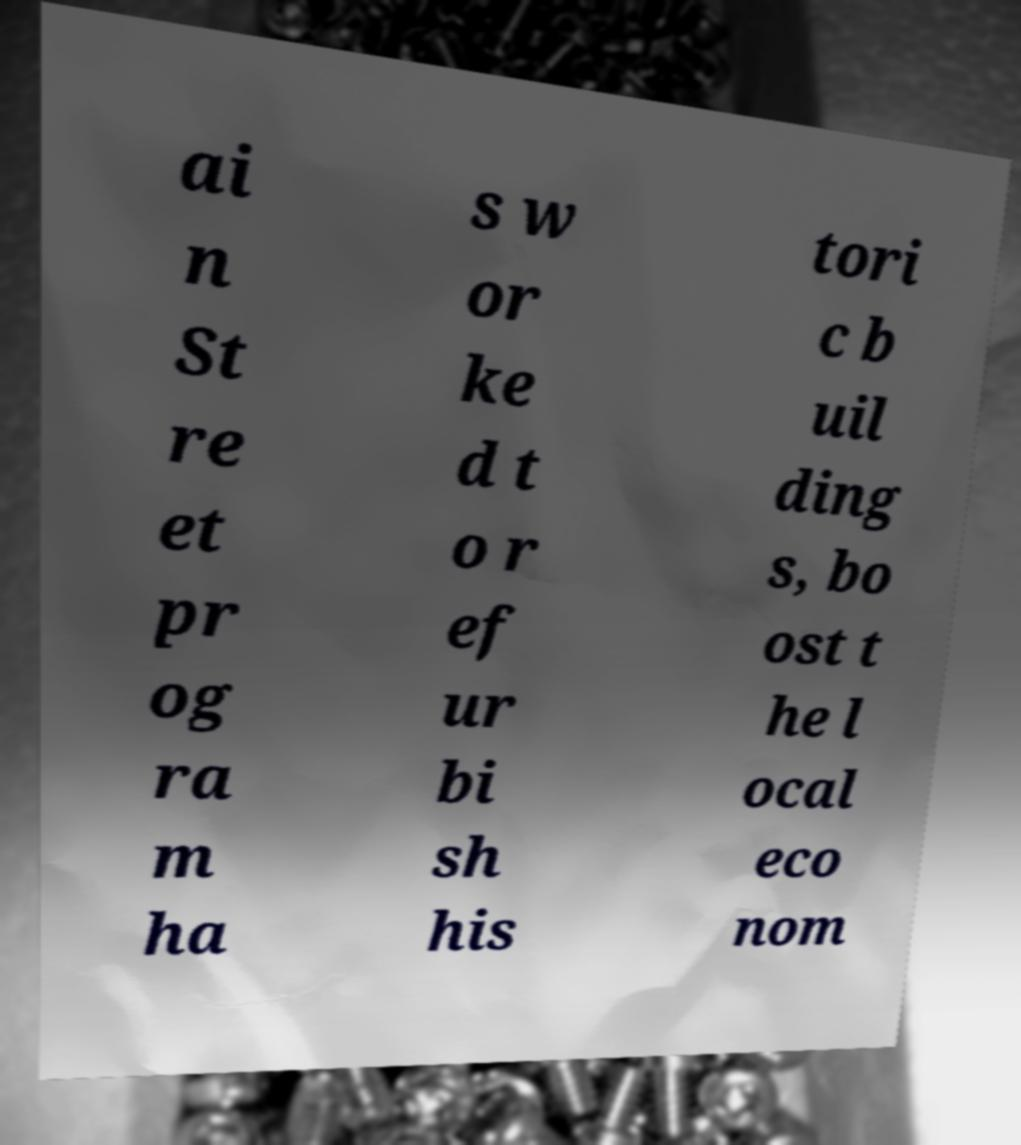Please identify and transcribe the text found in this image. ai n St re et pr og ra m ha s w or ke d t o r ef ur bi sh his tori c b uil ding s, bo ost t he l ocal eco nom 